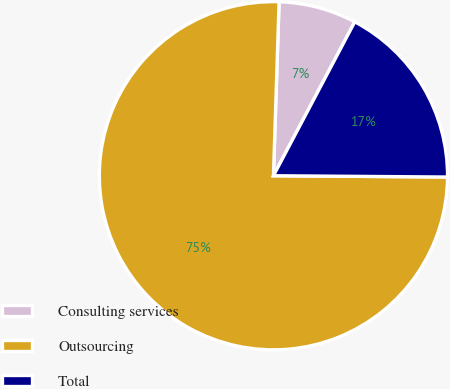Convert chart to OTSL. <chart><loc_0><loc_0><loc_500><loc_500><pie_chart><fcel>Consulting services<fcel>Outsourcing<fcel>Total<nl><fcel>7.22%<fcel>75.4%<fcel>17.38%<nl></chart> 